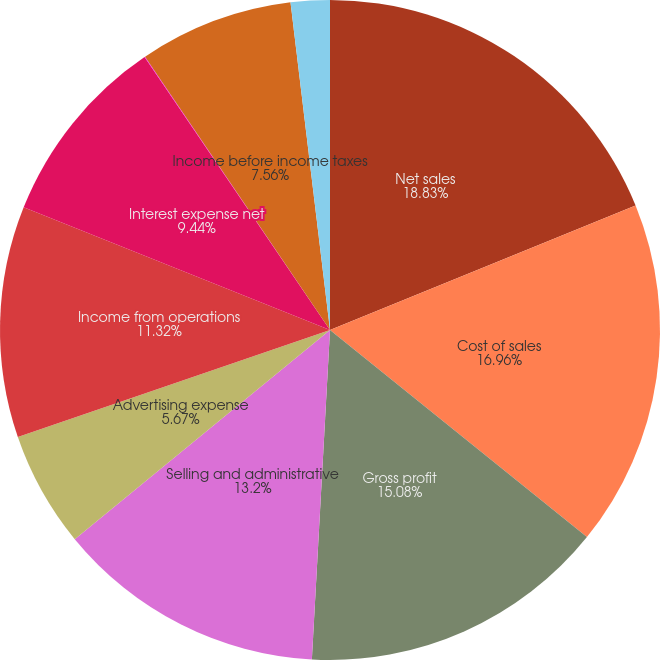<chart> <loc_0><loc_0><loc_500><loc_500><pie_chart><fcel>Net sales<fcel>Cost of sales<fcel>Gross profit<fcel>Selling and administrative<fcel>Advertising expense<fcel>Income from operations<fcel>Interest expense net<fcel>Net loss on extinguishments of<fcel>Income before income taxes<fcel>Income tax expense<nl><fcel>18.84%<fcel>16.96%<fcel>15.08%<fcel>13.2%<fcel>5.67%<fcel>11.32%<fcel>9.44%<fcel>0.03%<fcel>7.56%<fcel>1.91%<nl></chart> 